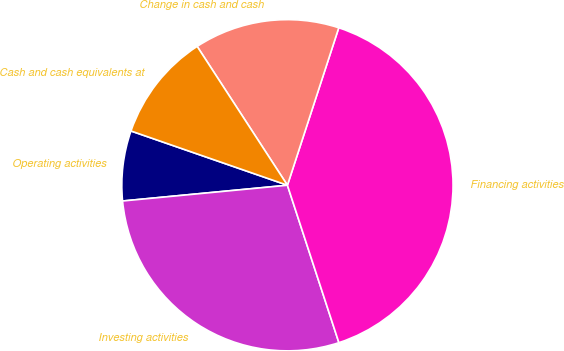Convert chart to OTSL. <chart><loc_0><loc_0><loc_500><loc_500><pie_chart><fcel>Operating activities<fcel>Investing activities<fcel>Financing activities<fcel>Change in cash and cash<fcel>Cash and cash equivalents at<nl><fcel>6.83%<fcel>28.51%<fcel>39.95%<fcel>14.19%<fcel>10.51%<nl></chart> 